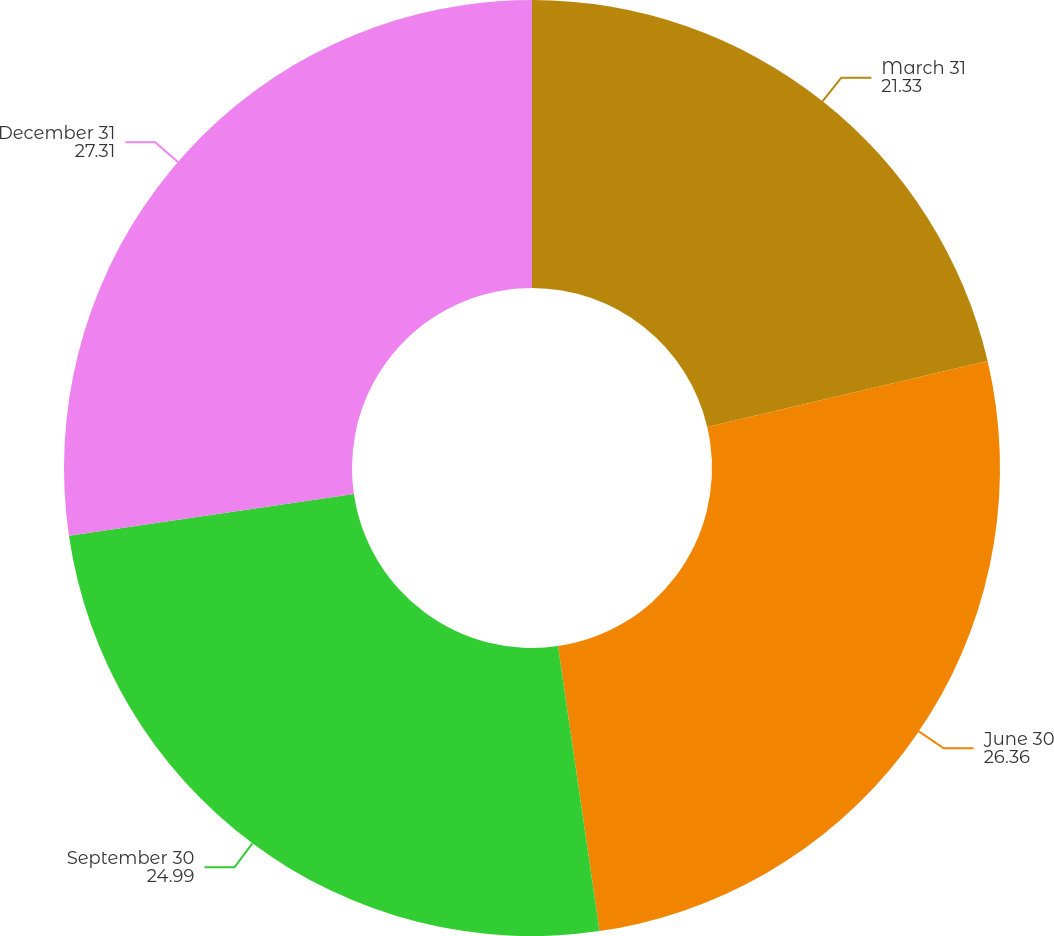<chart> <loc_0><loc_0><loc_500><loc_500><pie_chart><fcel>March 31<fcel>June 30<fcel>September 30<fcel>December 31<nl><fcel>21.33%<fcel>26.36%<fcel>24.99%<fcel>27.31%<nl></chart> 